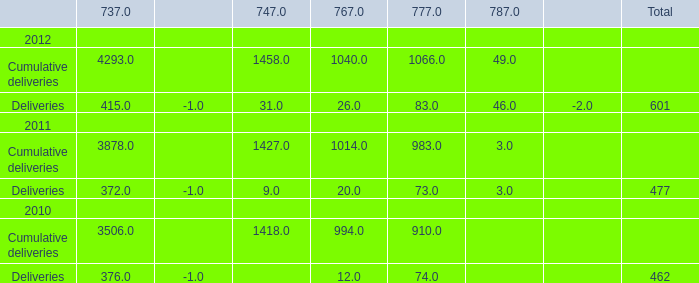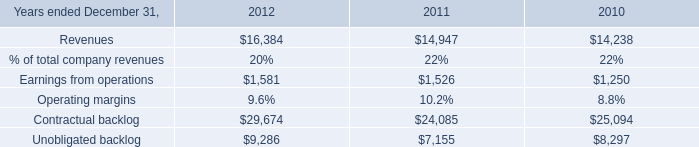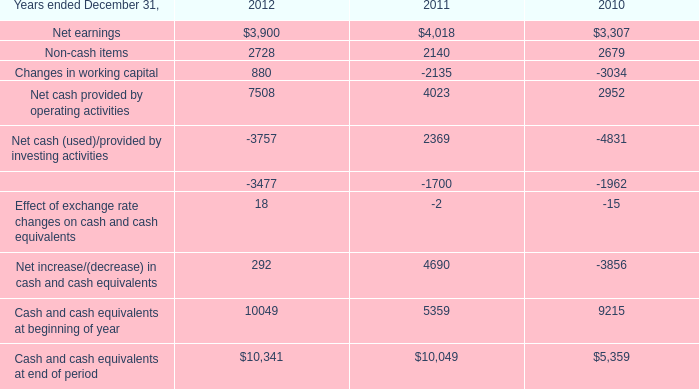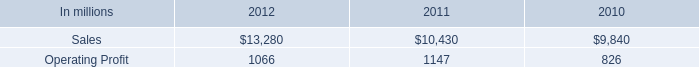What's the sum of Net earnings of 2011, and Earnings from operations of 2012 ? 
Computations: (4018.0 + 1581.0)
Answer: 5599.0. 